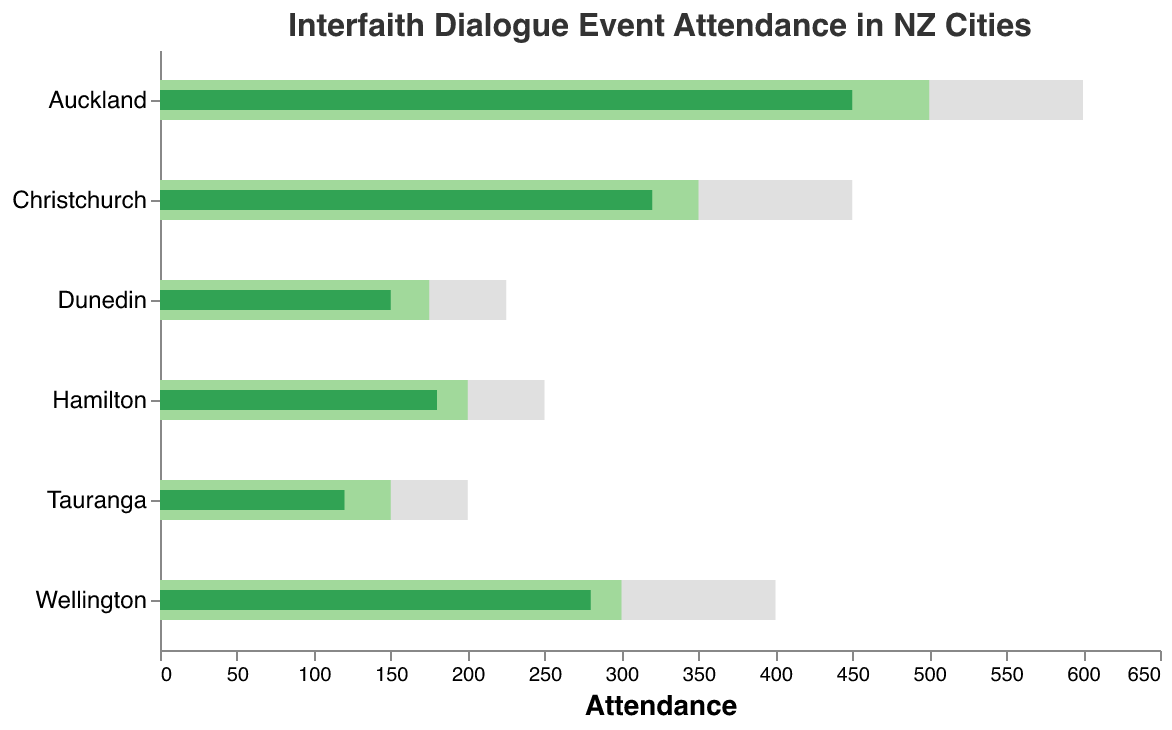What is the title of the chart? The title of the chart is usually found at the top of the figure. Here, we can see "Interfaith Dialogue Event Attendance in NZ Cities" prominently displayed.
Answer: Interfaith Dialogue Event Attendance in NZ Cities Which city has the highest actual attendance? To find the highest attendance, we look for the longest green bar representing actual attendance. Auckland's bar is the longest in this context.
Answer: Auckland For Wellington, what is the difference between actual attendance and target attendance? For this, subtract Wellington's actual attendance (280) from its target attendance (300). This calculation is 300 - 280.
Answer: 20 How many cities have an actual attendance above 300? By observing the lengths of the actual attendance bars and comparing them to the scale, we see that Auckland (450) and Christchurch (320) both have attendances above 300.
Answer: 2 Which city is closest to achieving its target attendance? The city close to its target is the one with the smallest gap between the actual and target attendances. By comparing, Wellington has a difference of 20 (300 - 280), which is smaller than other differences.
Answer: Wellington What is the maximum capacity for Hamilton? The maximum capacity can be identified by looking at the light grey bar for Hamilton, which ends at 250.
Answer: 250 Which city has the largest difference between actual attendance and maximum capacity? We need to find the city with the biggest gap (Max Capacity - Actual Attendance). For each city:
Auckland: 600 - 450 = 150 
Wellington: 400 - 280 = 120 
Christchurch: 450 - 320 = 130 
Hamilton: 250 - 180 = 70 
Dunedin: 225 - 150 = 75 
Tauranga: 200 - 120 = 80
Auckland has the largest difference.
Answer: Auckland What is the combined target attendance for Christchurch and Dunedin? Add the target attendances for Christchurch (350) and Dunedin (175). This is calculated as 350 + 175.
Answer: 525 Which cities have actual attendance less than half of their maximum capacity? Identify cities where the actual attendance bar is less than half the length of the maximum capacity bar. In other words, we check if Actual < 0.5 * Max Capacity for each city:
Auckland: 450 < 300 (False) 
Wellington: 280 < 200 (False) 
Christchurch: 320 < 225 (False) 
Hamilton: 180 < 125 (False) 
Dunedin: 150 < 112.5 (False) 
Tauranga: 120 < 100 (False)
Since no city meets these criteria, no city has actual attendance less than half its maximum capacity.
Answer: None 